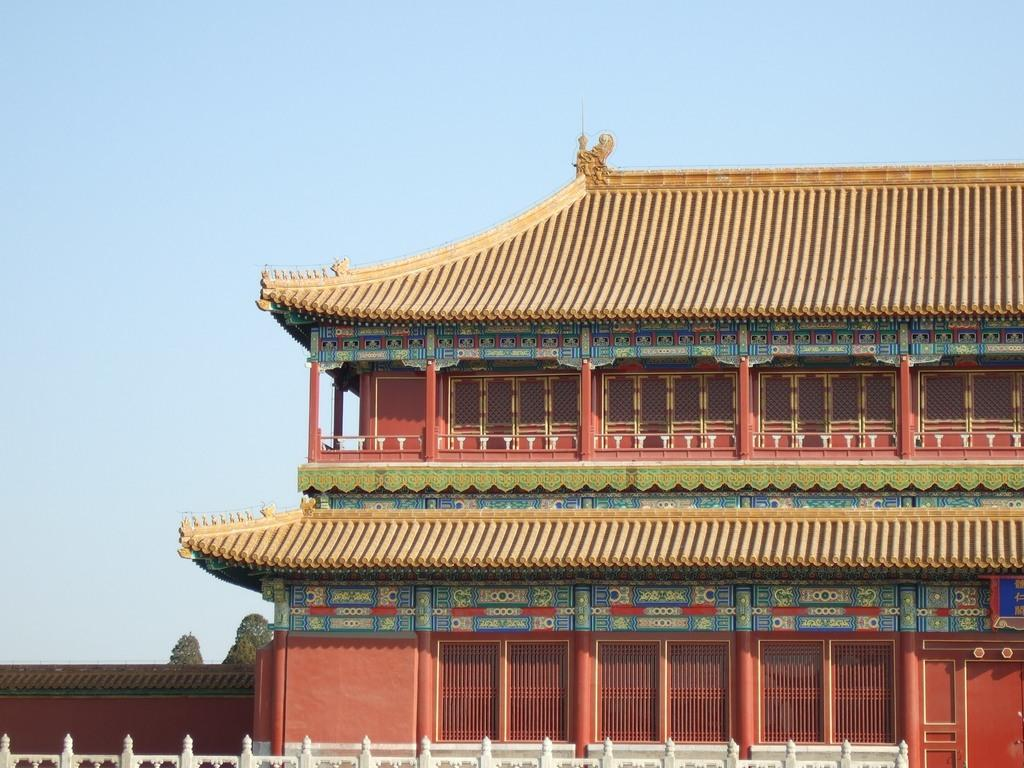What type of structure is in the image? There is a building in the image. What architectural features can be seen on the building? The building has pillars and windows. What can be seen in the background of the image? There are trees and the sky visible in the background of the image. What type of barrier is at the bottom of the image? There is fencing at the bottom of the image. What type of rock is being hammered by the person in the image? There is no person or rock present in the image; it features a building with pillars and windows, trees and sky in the background, and fencing at the bottom. 